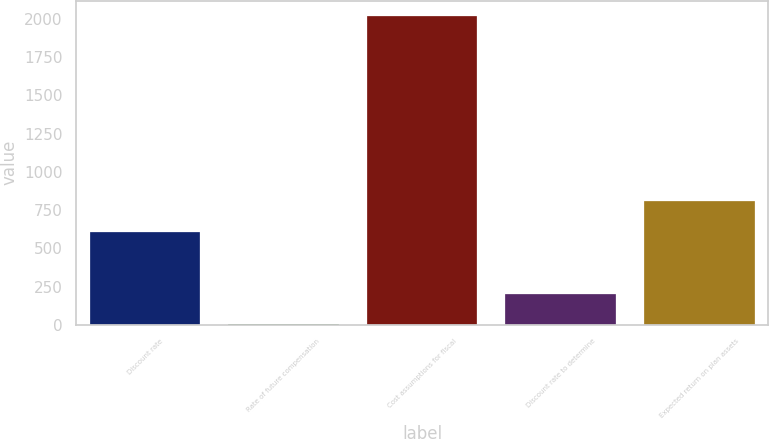Convert chart to OTSL. <chart><loc_0><loc_0><loc_500><loc_500><bar_chart><fcel>Discount rate<fcel>Rate of future compensation<fcel>Cost assumptions for fiscal<fcel>Discount rate to determine<fcel>Expected return on plan assets<nl><fcel>607.32<fcel>2.76<fcel>2018<fcel>204.28<fcel>808.84<nl></chart> 